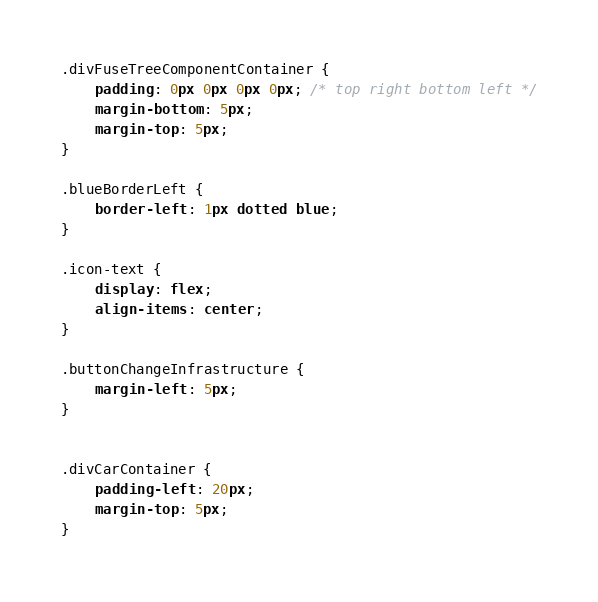<code> <loc_0><loc_0><loc_500><loc_500><_CSS_>

.divFuseTreeComponentContainer {
    padding: 0px 0px 0px 0px; /* top right bottom left */
    margin-bottom: 5px; 
    margin-top: 5px; 
}

.blueBorderLeft {
    border-left: 1px dotted blue; 
}

.icon-text {
    display: flex;
    align-items: center;
}

.buttonChangeInfrastructure {
    margin-left: 5px; 
}


.divCarContainer {
    padding-left: 20px; 
    margin-top: 5px; 
}


</code> 